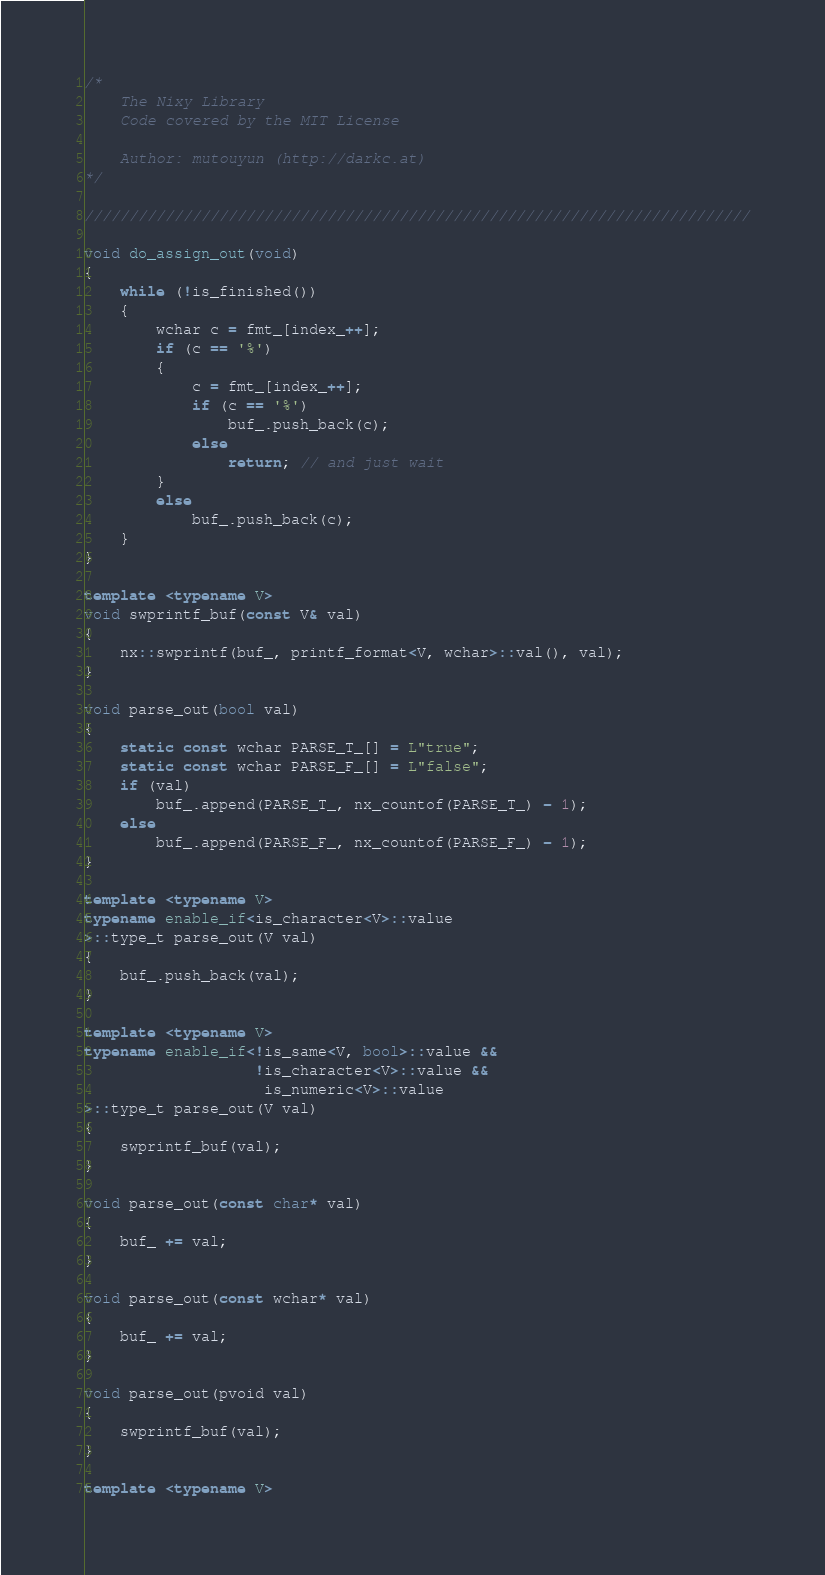<code> <loc_0><loc_0><loc_500><loc_500><_C++_>/*
    The Nixy Library
    Code covered by the MIT License

    Author: mutouyun (http://darkc.at)
*/

//////////////////////////////////////////////////////////////////////////

void do_assign_out(void)
{
    while (!is_finished())
    {
        wchar c = fmt_[index_++];
        if (c == '%')
        {
            c = fmt_[index_++];
            if (c == '%')
                buf_.push_back(c);
            else
                return; // and just wait
        }
        else
            buf_.push_back(c);
    }
}

template <typename V>
void swprintf_buf(const V& val)
{
    nx::swprintf(buf_, printf_format<V, wchar>::val(), val);
}

void parse_out(bool val)
{
    static const wchar PARSE_T_[] = L"true";
    static const wchar PARSE_F_[] = L"false";
    if (val)
        buf_.append(PARSE_T_, nx_countof(PARSE_T_) - 1);
    else
        buf_.append(PARSE_F_, nx_countof(PARSE_F_) - 1);
}

template <typename V>
typename enable_if<is_character<V>::value
>::type_t parse_out(V val)
{
    buf_.push_back(val);
}

template <typename V>
typename enable_if<!is_same<V, bool>::value && 
                   !is_character<V>::value && 
                    is_numeric<V>::value
>::type_t parse_out(V val)
{
    swprintf_buf(val);
}

void parse_out(const char* val)
{
    buf_ += val;
}

void parse_out(const wchar* val)
{
    buf_ += val;
}

void parse_out(pvoid val)
{
    swprintf_buf(val);
}

template <typename V></code> 